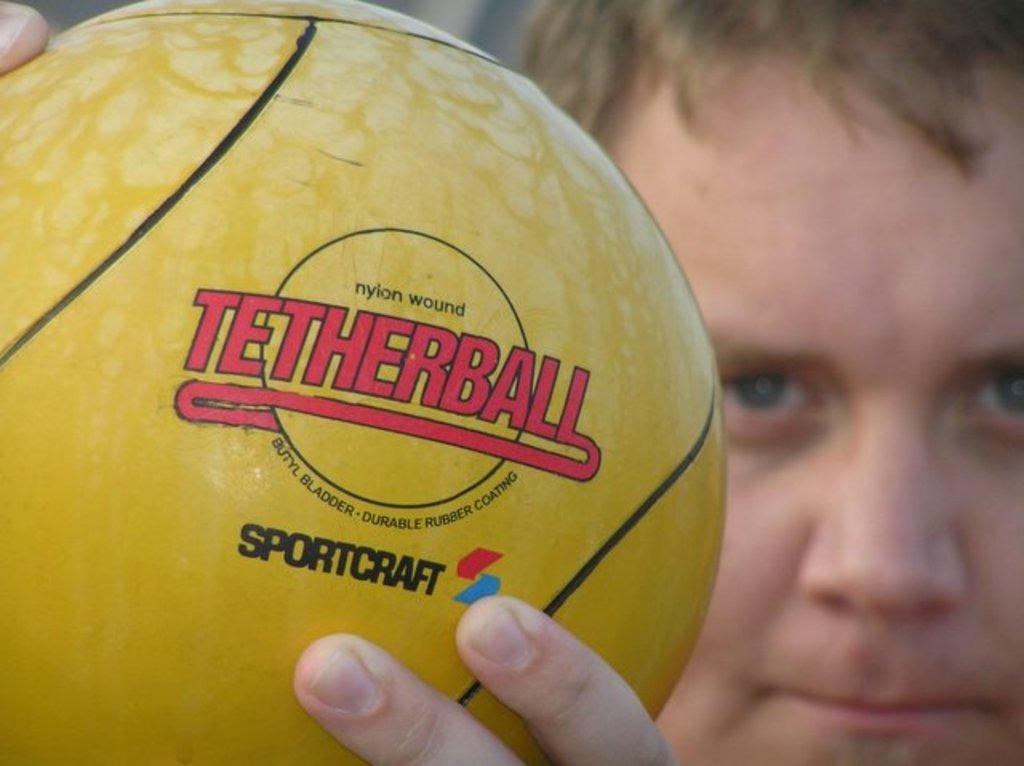<image>
Create a compact narrative representing the image presented. Boy holding a yellow tetherball in his hands 